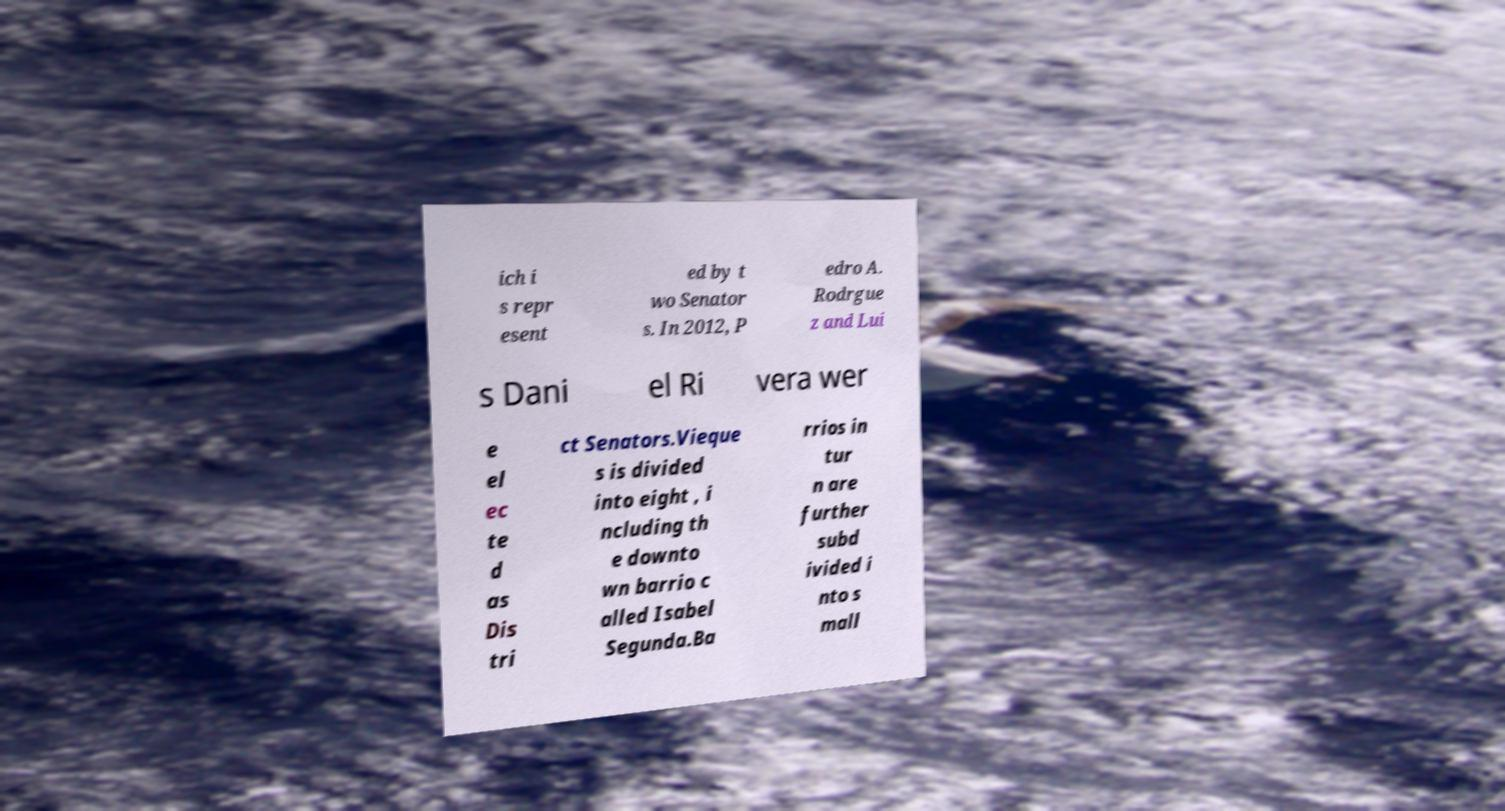Please read and relay the text visible in this image. What does it say? ich i s repr esent ed by t wo Senator s. In 2012, P edro A. Rodrgue z and Lui s Dani el Ri vera wer e el ec te d as Dis tri ct Senators.Vieque s is divided into eight , i ncluding th e downto wn barrio c alled Isabel Segunda.Ba rrios in tur n are further subd ivided i nto s mall 